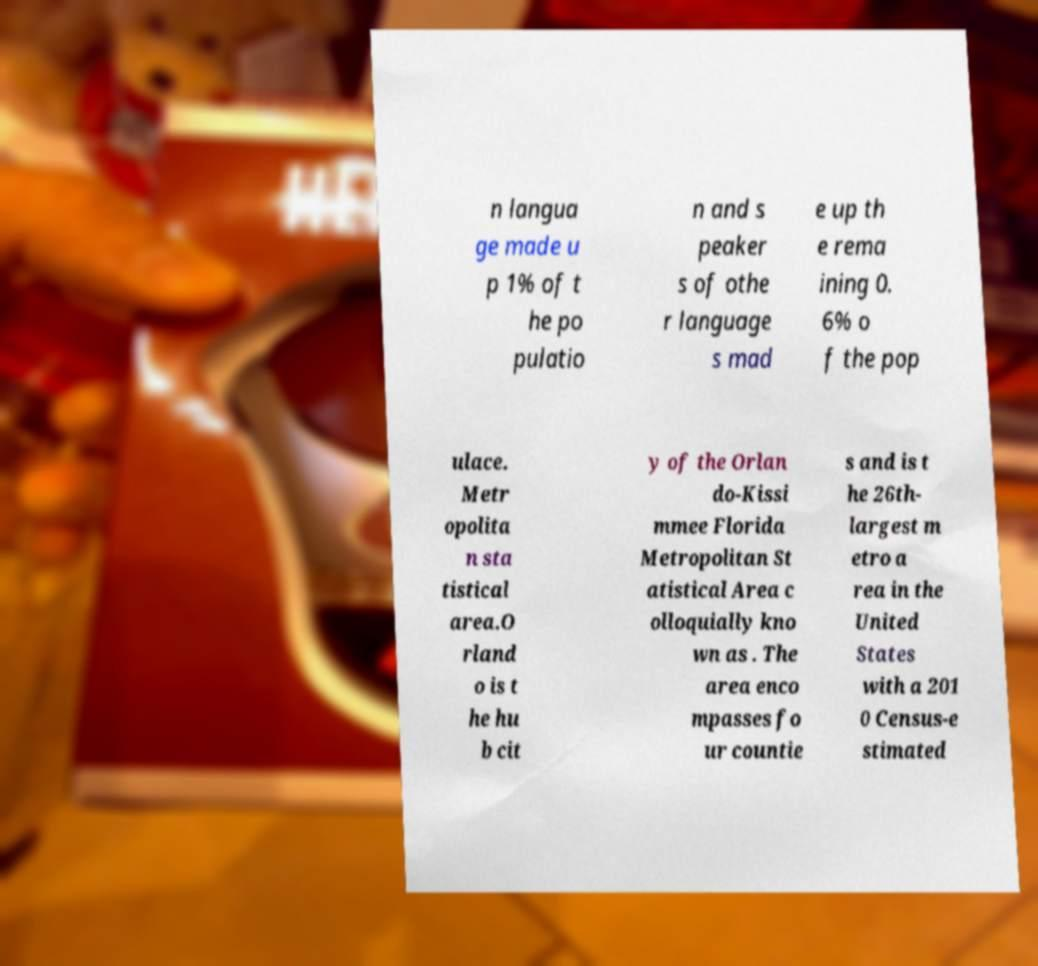What messages or text are displayed in this image? I need them in a readable, typed format. n langua ge made u p 1% of t he po pulatio n and s peaker s of othe r language s mad e up th e rema ining 0. 6% o f the pop ulace. Metr opolita n sta tistical area.O rland o is t he hu b cit y of the Orlan do-Kissi mmee Florida Metropolitan St atistical Area c olloquially kno wn as . The area enco mpasses fo ur countie s and is t he 26th- largest m etro a rea in the United States with a 201 0 Census-e stimated 